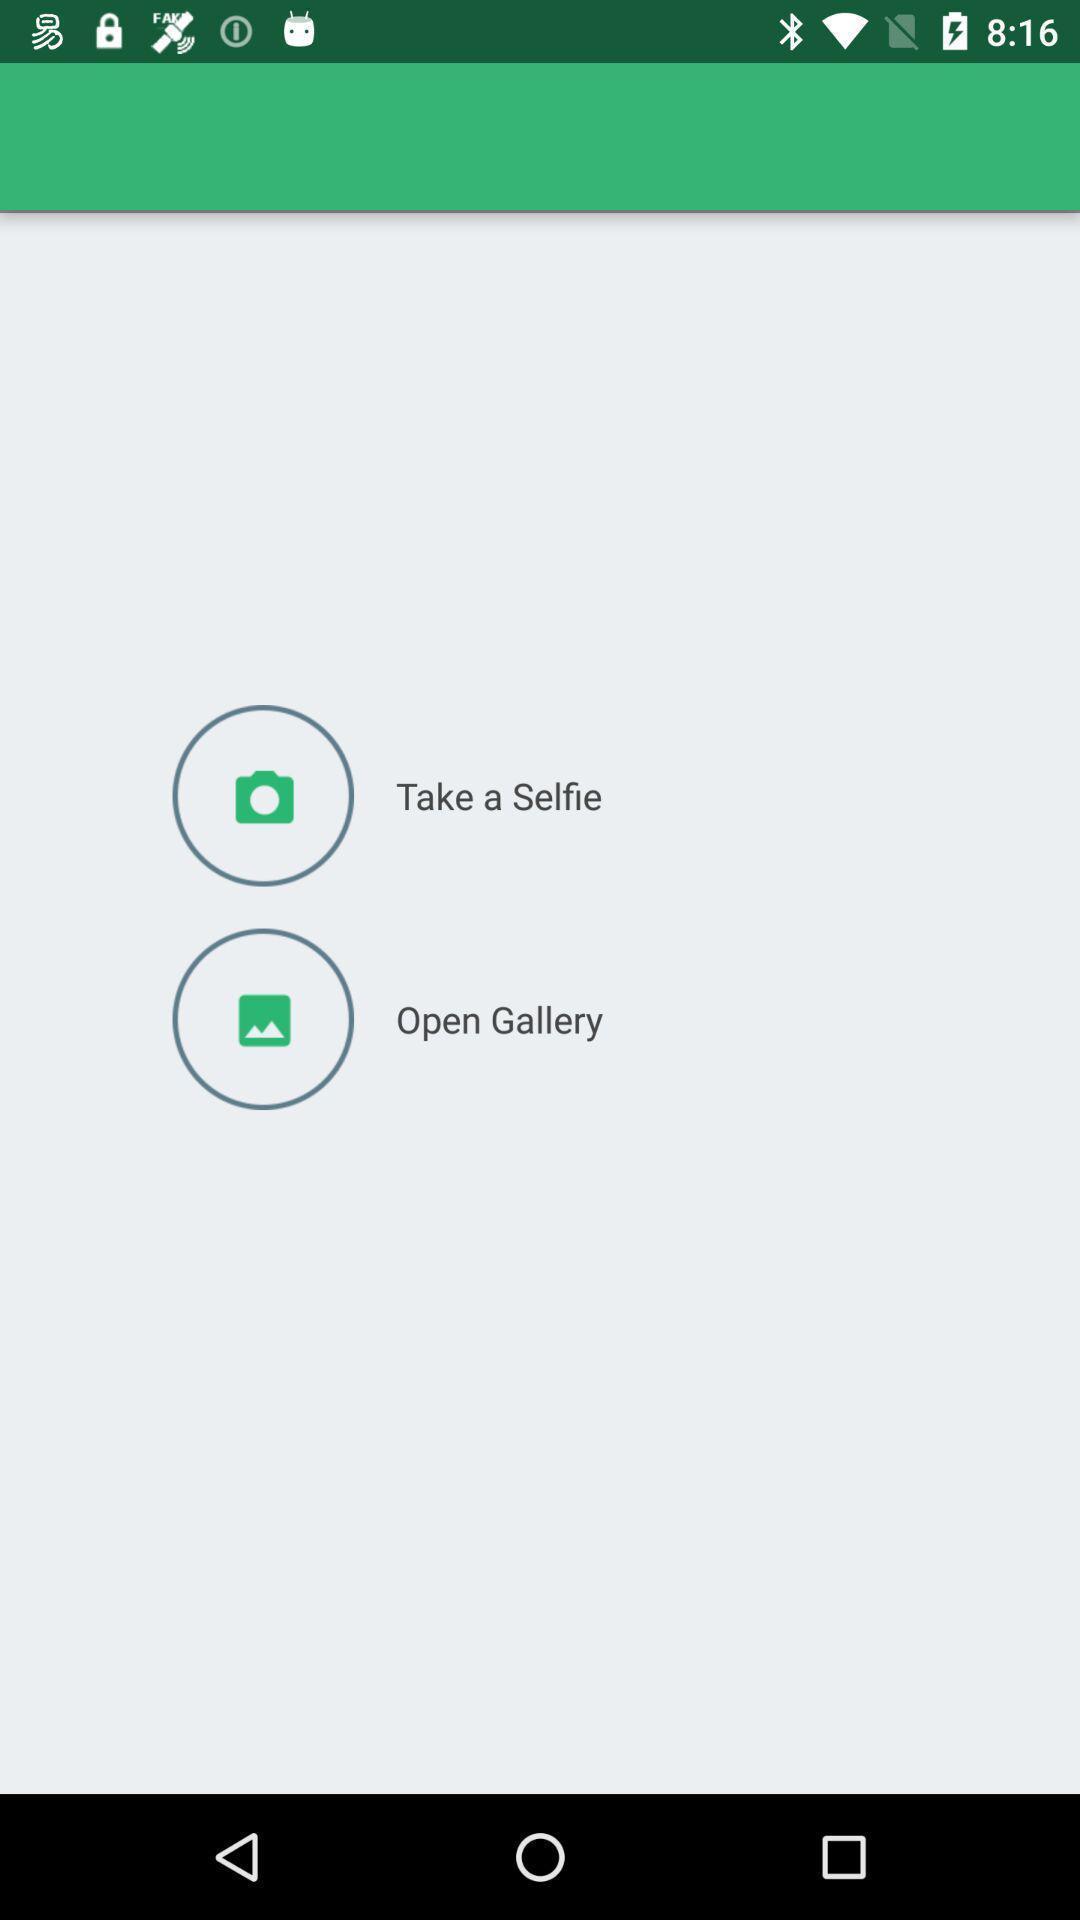Describe the key features of this screenshot. Page showing options to create profile photo in multimedia app. 